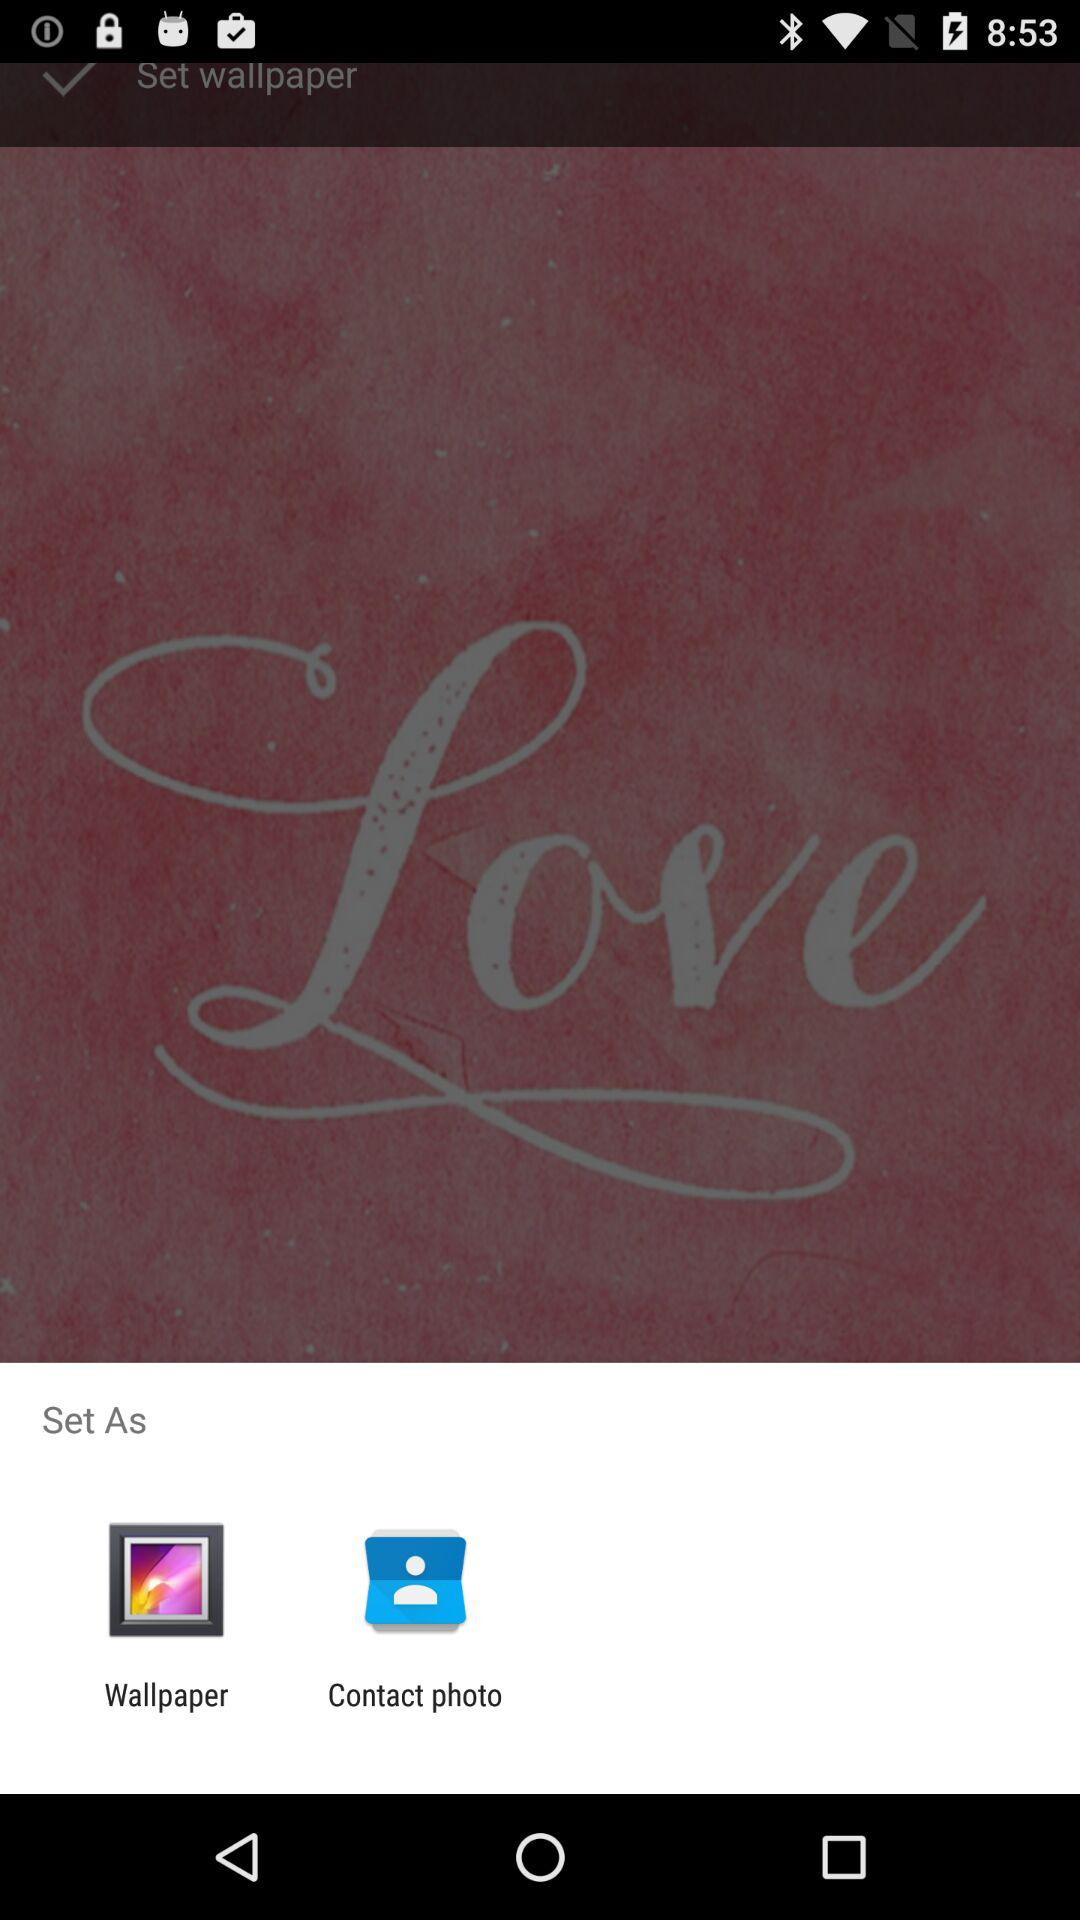What are the options available in "Set As"? The options are "Wallpaper" and "Contact photo". 